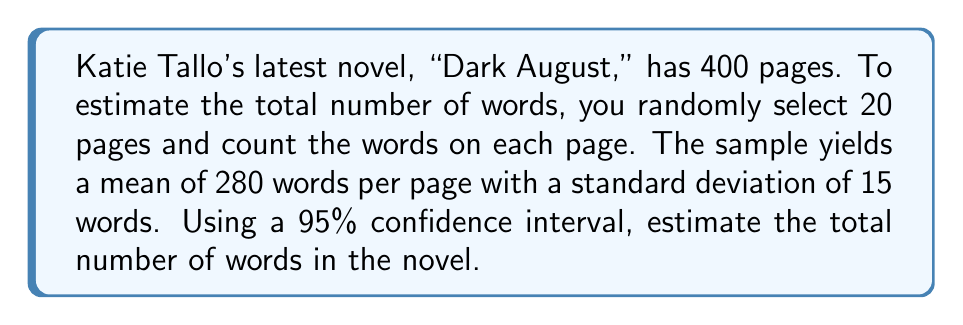Solve this math problem. To estimate the total number of words in Katie Tallo's novel using statistical sampling methods, we'll follow these steps:

1. Calculate the standard error of the mean:
   $SE = \frac{s}{\sqrt{n}}$, where $s$ is the sample standard deviation and $n$ is the sample size.
   $SE = \frac{15}{\sqrt{20}} = 3.35$

2. Determine the t-value for a 95% confidence interval with 19 degrees of freedom (n-1):
   $t_{0.025, 19} = 2.093$ (from t-distribution table)

3. Calculate the margin of error:
   $ME = t_{0.025, 19} \times SE = 2.093 \times 3.35 = 7.01$

4. Compute the 95% confidence interval for the mean words per page:
   $CI = \bar{x} \pm ME = 280 \pm 7.01$
   Lower bound: $280 - 7.01 = 272.99$
   Upper bound: $280 + 7.01 = 287.01$

5. Estimate the total number of words by multiplying the confidence interval bounds by the total number of pages:
   Lower estimate: $272.99 \times 400 = 109,196$
   Upper estimate: $287.01 \times 400 = 114,804$

Therefore, we can estimate with 95% confidence that the total number of words in Katie Tallo's "Dark August" is between 109,196 and 114,804.
Answer: 109,196 to 114,804 words 